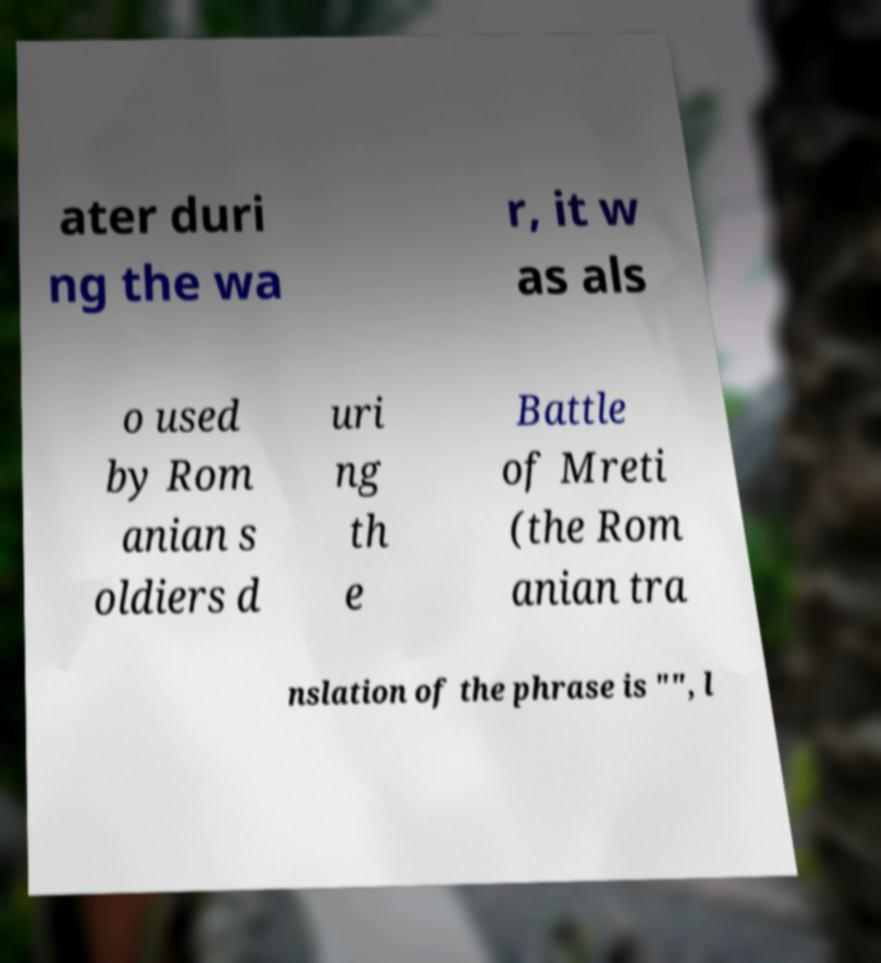Can you read and provide the text displayed in the image?This photo seems to have some interesting text. Can you extract and type it out for me? ater duri ng the wa r, it w as als o used by Rom anian s oldiers d uri ng th e Battle of Mreti (the Rom anian tra nslation of the phrase is "", l 